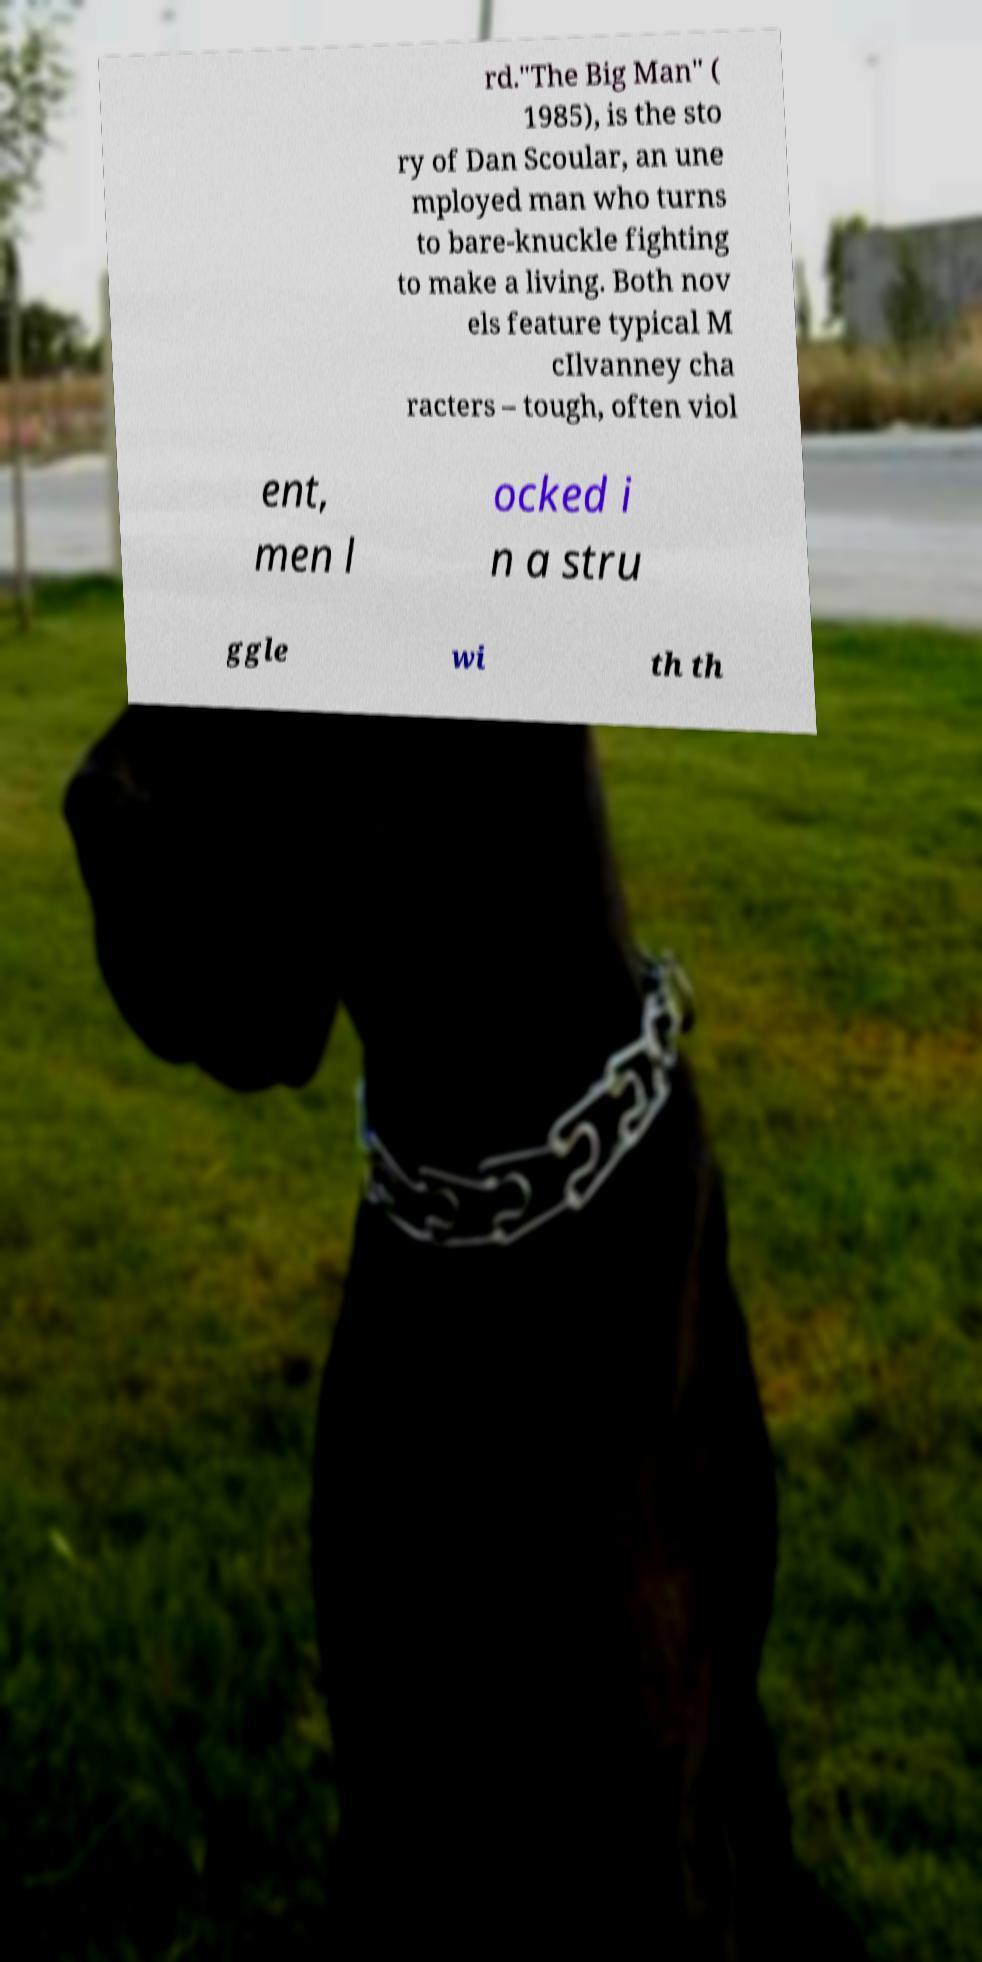Please read and relay the text visible in this image. What does it say? rd."The Big Man" ( 1985), is the sto ry of Dan Scoular, an une mployed man who turns to bare-knuckle fighting to make a living. Both nov els feature typical M cIlvanney cha racters – tough, often viol ent, men l ocked i n a stru ggle wi th th 